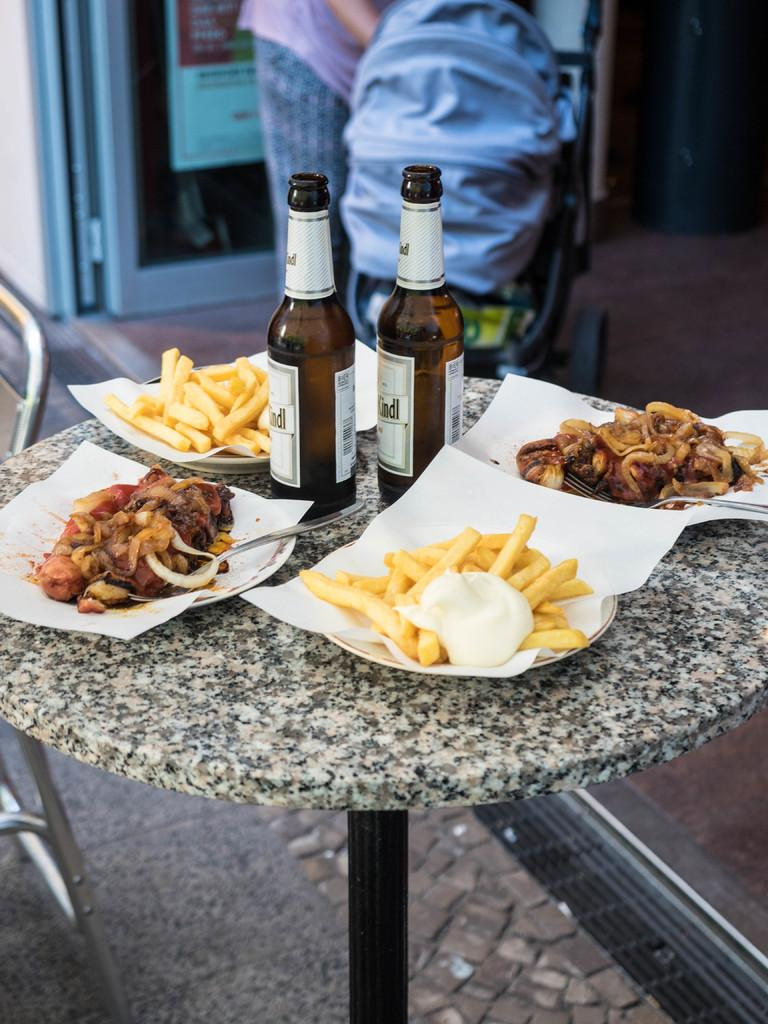What piece of furniture can be seen in the image? There is a table in the image. What is placed on the table? Two wine bottles and delicious food are visible on the table. Can you describe anything in the background of the image? There is a bag in the background of the image. Where is the bag located? The bag is kept on a chair. What type of coil can be seen in the image? There is no coil present in the image. How many people are in the crowd in the image? There is no crowd present in the image. 